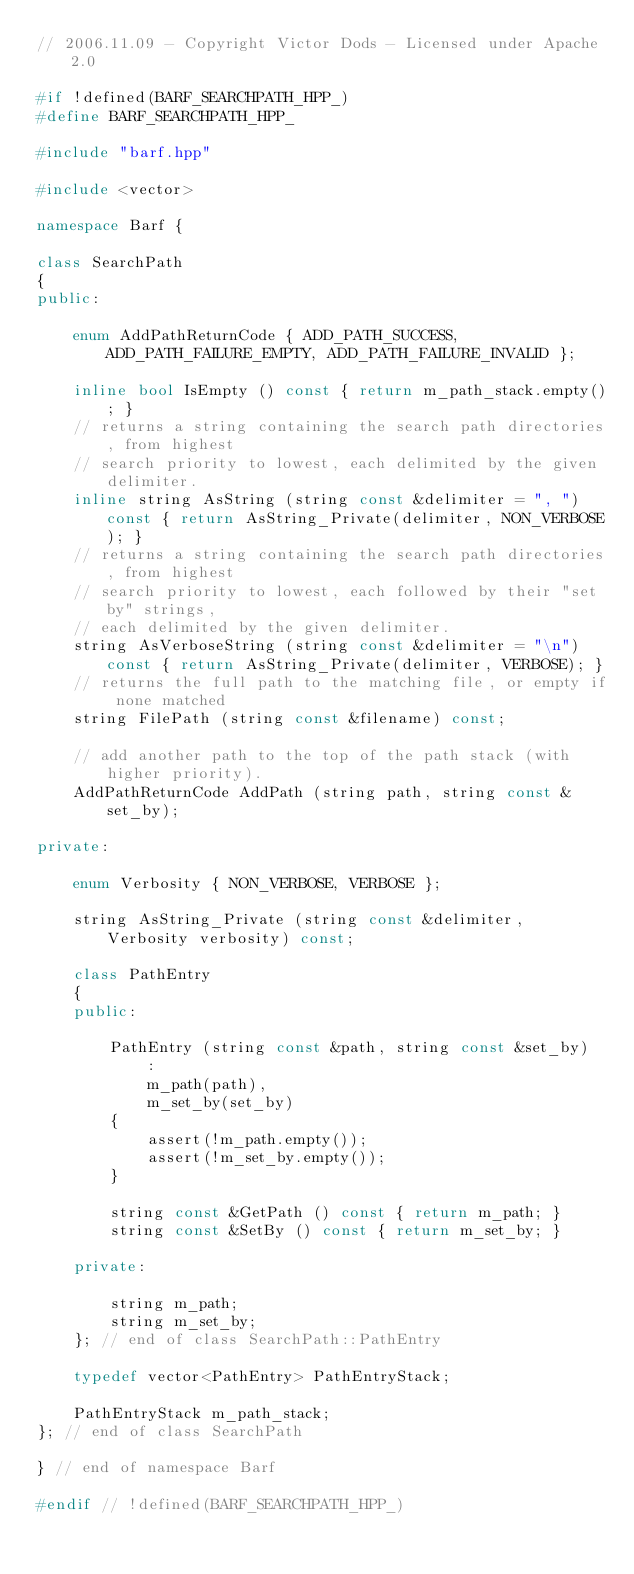<code> <loc_0><loc_0><loc_500><loc_500><_C++_>// 2006.11.09 - Copyright Victor Dods - Licensed under Apache 2.0

#if !defined(BARF_SEARCHPATH_HPP_)
#define BARF_SEARCHPATH_HPP_

#include "barf.hpp"

#include <vector>

namespace Barf {

class SearchPath
{
public:

    enum AddPathReturnCode { ADD_PATH_SUCCESS, ADD_PATH_FAILURE_EMPTY, ADD_PATH_FAILURE_INVALID };

    inline bool IsEmpty () const { return m_path_stack.empty(); }
    // returns a string containing the search path directories, from highest
    // search priority to lowest, each delimited by the given delimiter.
    inline string AsString (string const &delimiter = ", ") const { return AsString_Private(delimiter, NON_VERBOSE); }
    // returns a string containing the search path directories, from highest
    // search priority to lowest, each followed by their "set by" strings, 
    // each delimited by the given delimiter.
    string AsVerboseString (string const &delimiter = "\n") const { return AsString_Private(delimiter, VERBOSE); }
    // returns the full path to the matching file, or empty if none matched
    string FilePath (string const &filename) const;

    // add another path to the top of the path stack (with higher priority).
    AddPathReturnCode AddPath (string path, string const &set_by);

private:

    enum Verbosity { NON_VERBOSE, VERBOSE };

    string AsString_Private (string const &delimiter, Verbosity verbosity) const;

    class PathEntry
    {
    public:

        PathEntry (string const &path, string const &set_by)
            :
            m_path(path),
            m_set_by(set_by)
        {
            assert(!m_path.empty());
            assert(!m_set_by.empty());
        }

        string const &GetPath () const { return m_path; }
        string const &SetBy () const { return m_set_by; }

    private:

        string m_path;
        string m_set_by;
    }; // end of class SearchPath::PathEntry

    typedef vector<PathEntry> PathEntryStack;

    PathEntryStack m_path_stack;
}; // end of class SearchPath

} // end of namespace Barf

#endif // !defined(BARF_SEARCHPATH_HPP_)
</code> 